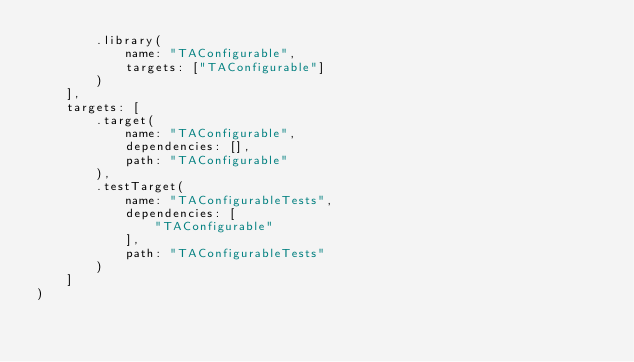Convert code to text. <code><loc_0><loc_0><loc_500><loc_500><_Swift_>        .library(
            name: "TAConfigurable",
            targets: ["TAConfigurable"]
        )
    ],
    targets: [
        .target(
            name: "TAConfigurable",
            dependencies: [],
            path: "TAConfigurable"
        ),
        .testTarget(
            name: "TAConfigurableTests",
            dependencies: [
                "TAConfigurable"
            ],
            path: "TAConfigurableTests"
        )
    ]
)
</code> 